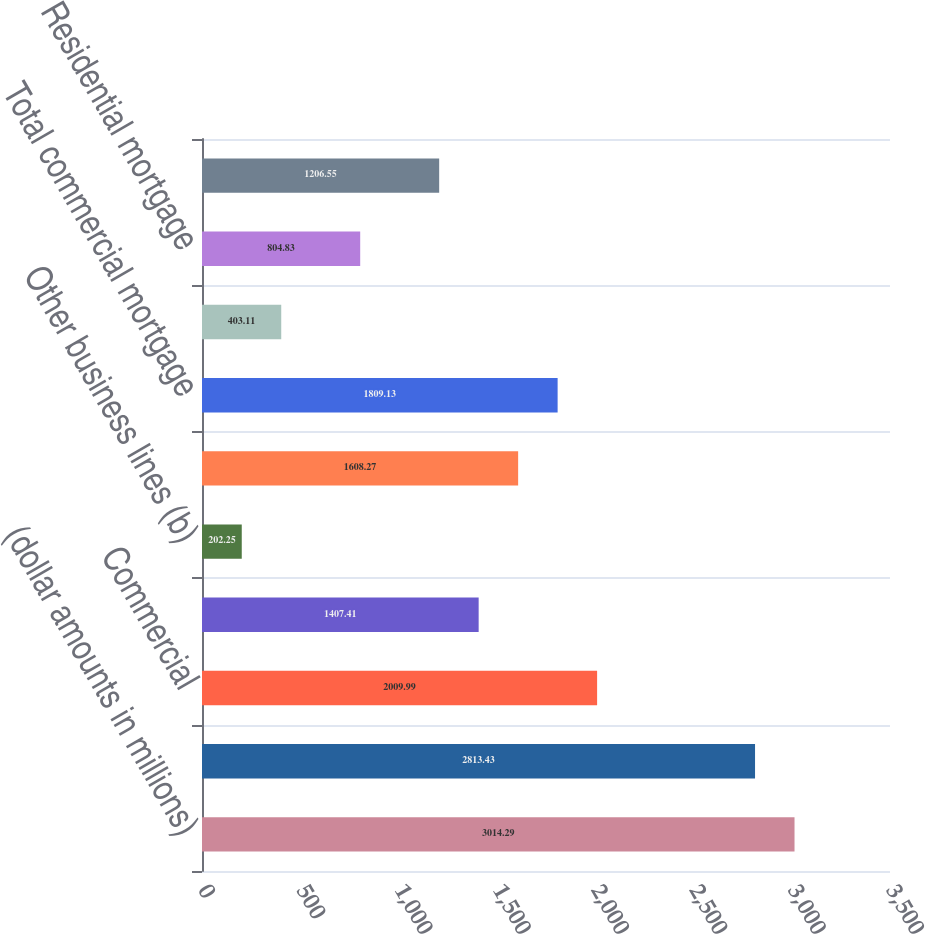<chart> <loc_0><loc_0><loc_500><loc_500><bar_chart><fcel>(dollar amounts in millions)<fcel>Balance at beginning of year<fcel>Commercial<fcel>Commercial Real Estate<fcel>Other business lines (b)<fcel>Total real estate construction<fcel>Total commercial mortgage<fcel>International<fcel>Residential mortgage<fcel>Consumer<nl><fcel>3014.29<fcel>2813.43<fcel>2009.99<fcel>1407.41<fcel>202.25<fcel>1608.27<fcel>1809.13<fcel>403.11<fcel>804.83<fcel>1206.55<nl></chart> 